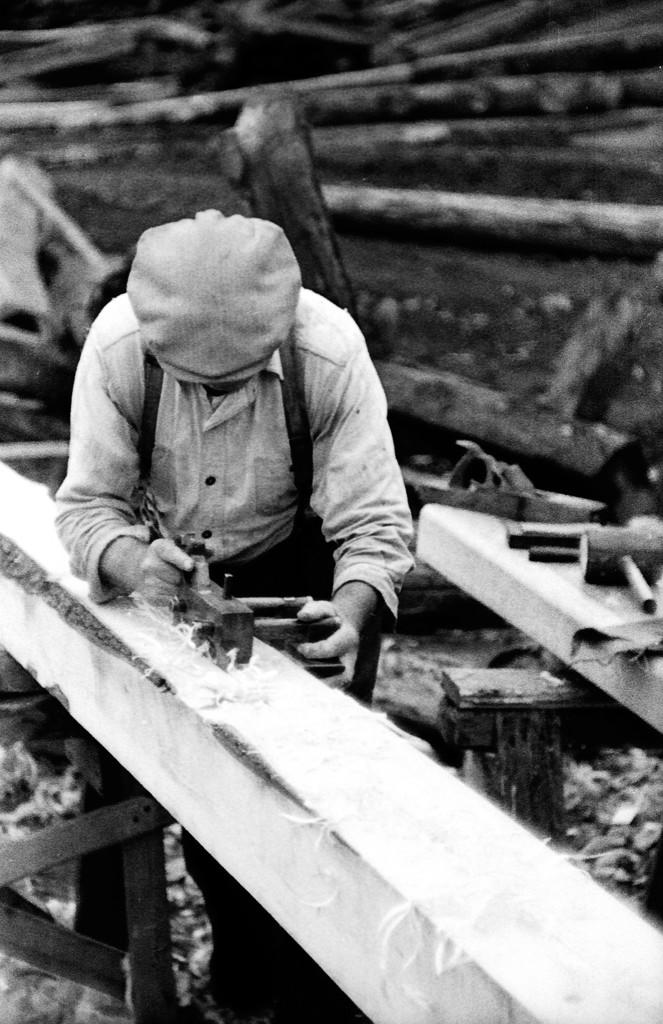What is the person in the image doing? The person is cleaning wood in the image. What object can be seen on the right side of the image? There is a hammer on the right side of the image. What can be seen in the background of the image? There are logs in the background of the image. What type of magic is being performed with the plastic bike in the image? There is no magic or bike present in the image; it features a person cleaning wood and a hammer. 